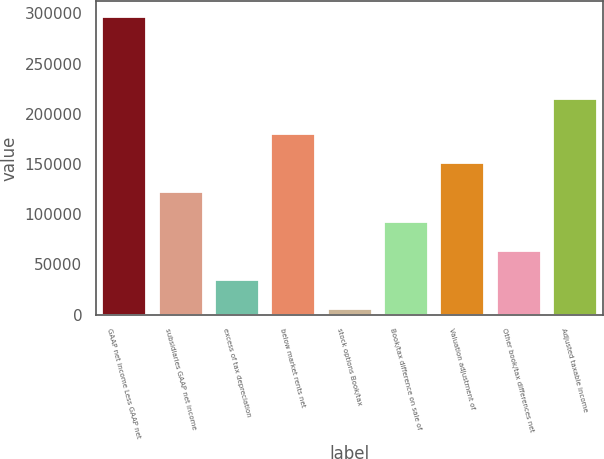Convert chart. <chart><loc_0><loc_0><loc_500><loc_500><bar_chart><fcel>GAAP net income Less GAAP net<fcel>subsidiaries GAAP net income<fcel>excess of tax depreciation<fcel>below market rents net<fcel>stock options Book/tax<fcel>Book/tax difference on sale of<fcel>Valuation adjustment of<fcel>Other book/tax differences net<fcel>Adjusted taxable income<nl><fcel>297137<fcel>122665<fcel>35428.7<fcel>180822<fcel>6350<fcel>93586.1<fcel>151744<fcel>64507.4<fcel>215924<nl></chart> 